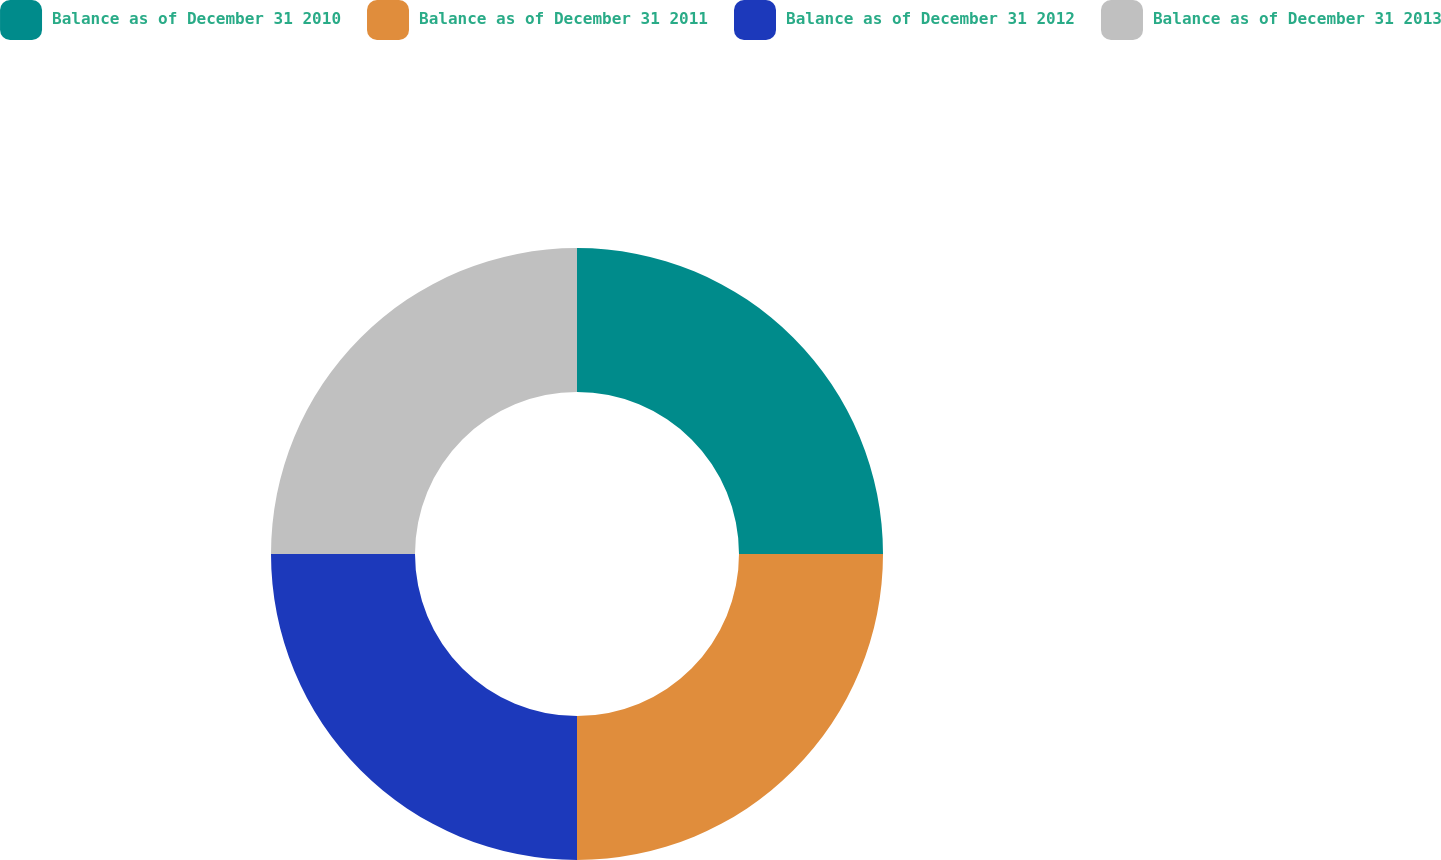Convert chart. <chart><loc_0><loc_0><loc_500><loc_500><pie_chart><fcel>Balance as of December 31 2010<fcel>Balance as of December 31 2011<fcel>Balance as of December 31 2012<fcel>Balance as of December 31 2013<nl><fcel>25.0%<fcel>25.0%<fcel>25.0%<fcel>25.0%<nl></chart> 